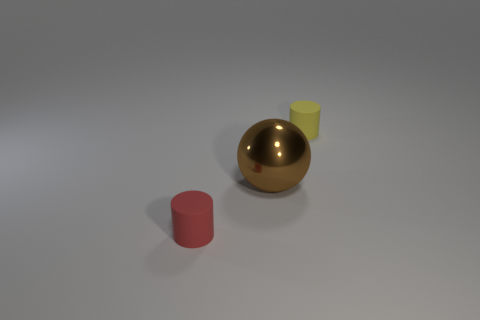Is the number of large brown metal spheres greater than the number of yellow matte spheres?
Provide a succinct answer. Yes. There is a big object right of the thing that is in front of the brown object behind the small red matte cylinder; what is it made of?
Offer a very short reply. Metal. What shape is the small rubber thing that is on the left side of the cylinder that is right of the brown sphere that is in front of the yellow matte object?
Offer a very short reply. Cylinder. There is a object that is both on the right side of the small red rubber thing and in front of the small yellow thing; what shape is it?
Provide a succinct answer. Sphere. What number of shiny spheres are left of the cylinder left of the cylinder that is behind the small red thing?
Offer a very short reply. 0. What is the size of the yellow matte object that is the same shape as the tiny red matte thing?
Your response must be concise. Small. Are there any other things that are the same size as the brown shiny object?
Make the answer very short. No. Are the cylinder left of the small yellow cylinder and the large brown thing made of the same material?
Offer a very short reply. No. The other rubber object that is the same shape as the yellow object is what color?
Keep it short and to the point. Red. What number of other things are there of the same color as the ball?
Offer a very short reply. 0. 